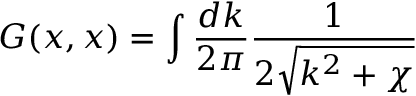<formula> <loc_0><loc_0><loc_500><loc_500>G ( x , x ) = \int \frac { d k } { 2 \pi } \frac { 1 } { 2 \sqrt { k ^ { 2 } + \chi } }</formula> 